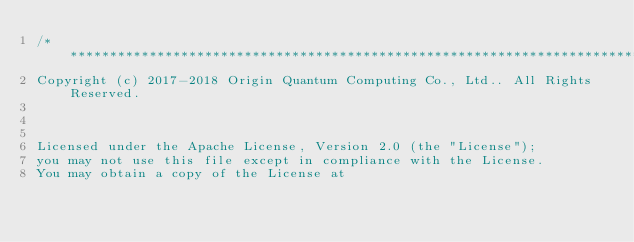<code> <loc_0><loc_0><loc_500><loc_500><_C++_>/******************************************************************************
Copyright (c) 2017-2018 Origin Quantum Computing Co., Ltd.. All Rights Reserved.


 
Licensed under the Apache License, Version 2.0 (the "License");
you may not use this file except in compliance with the License.
You may obtain a copy of the License at 
</code> 